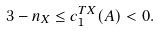<formula> <loc_0><loc_0><loc_500><loc_500>3 - n _ { X } \leq c _ { 1 } ^ { T X } ( A ) < 0 .</formula> 